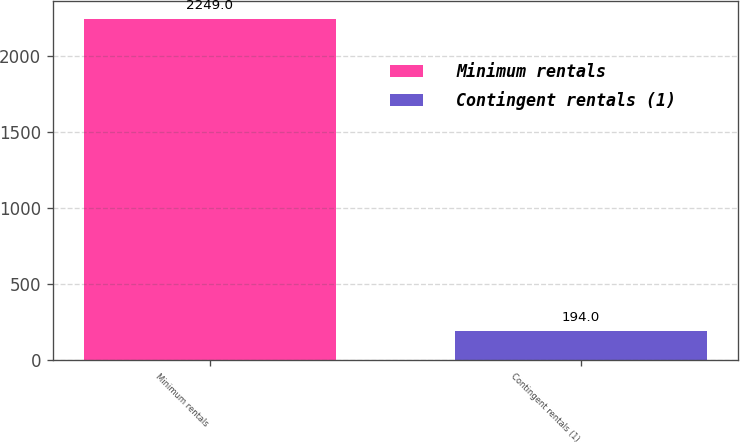Convert chart to OTSL. <chart><loc_0><loc_0><loc_500><loc_500><bar_chart><fcel>Minimum rentals<fcel>Contingent rentals (1)<nl><fcel>2249<fcel>194<nl></chart> 